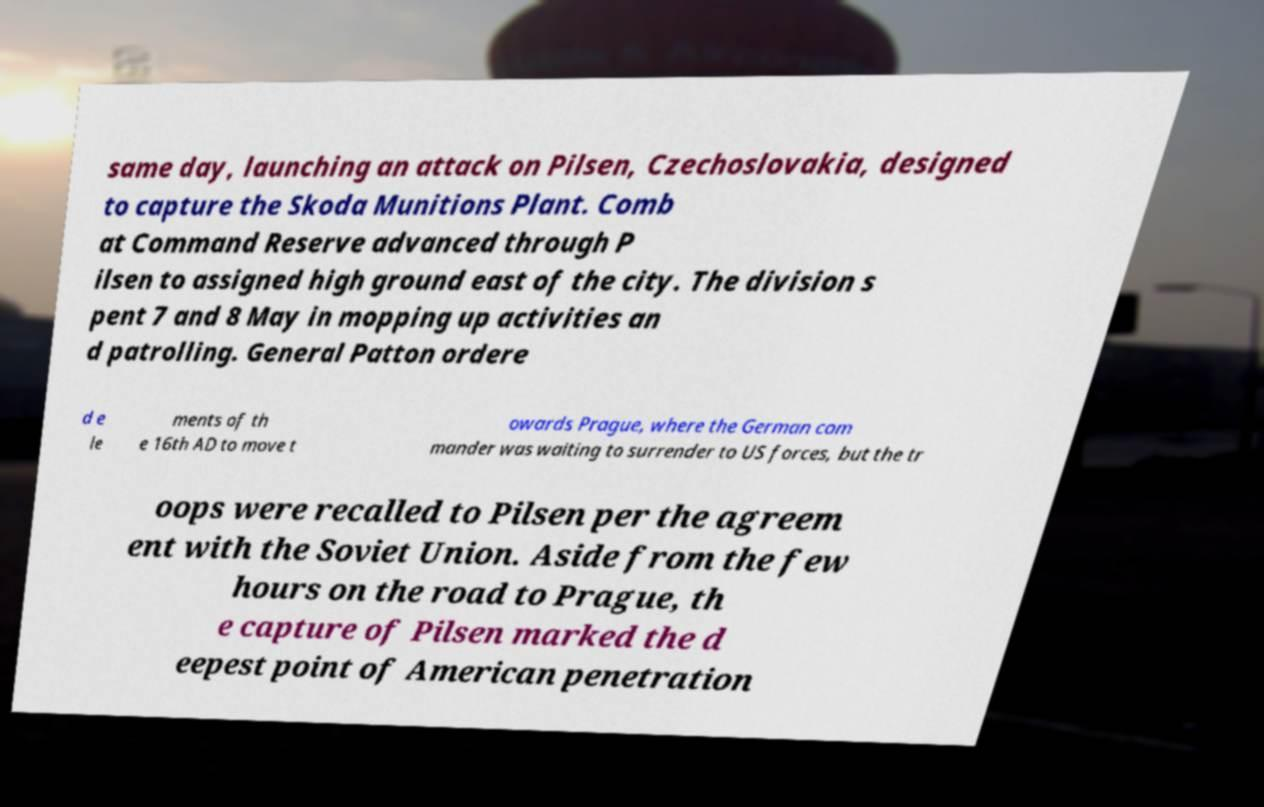Please read and relay the text visible in this image. What does it say? same day, launching an attack on Pilsen, Czechoslovakia, designed to capture the Skoda Munitions Plant. Comb at Command Reserve advanced through P ilsen to assigned high ground east of the city. The division s pent 7 and 8 May in mopping up activities an d patrolling. General Patton ordere d e le ments of th e 16th AD to move t owards Prague, where the German com mander was waiting to surrender to US forces, but the tr oops were recalled to Pilsen per the agreem ent with the Soviet Union. Aside from the few hours on the road to Prague, th e capture of Pilsen marked the d eepest point of American penetration 